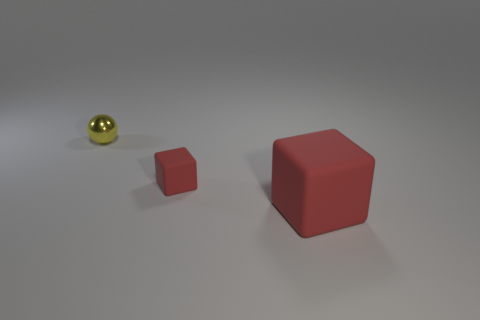What is the shape of the red rubber thing that is the same size as the metal object? cube 